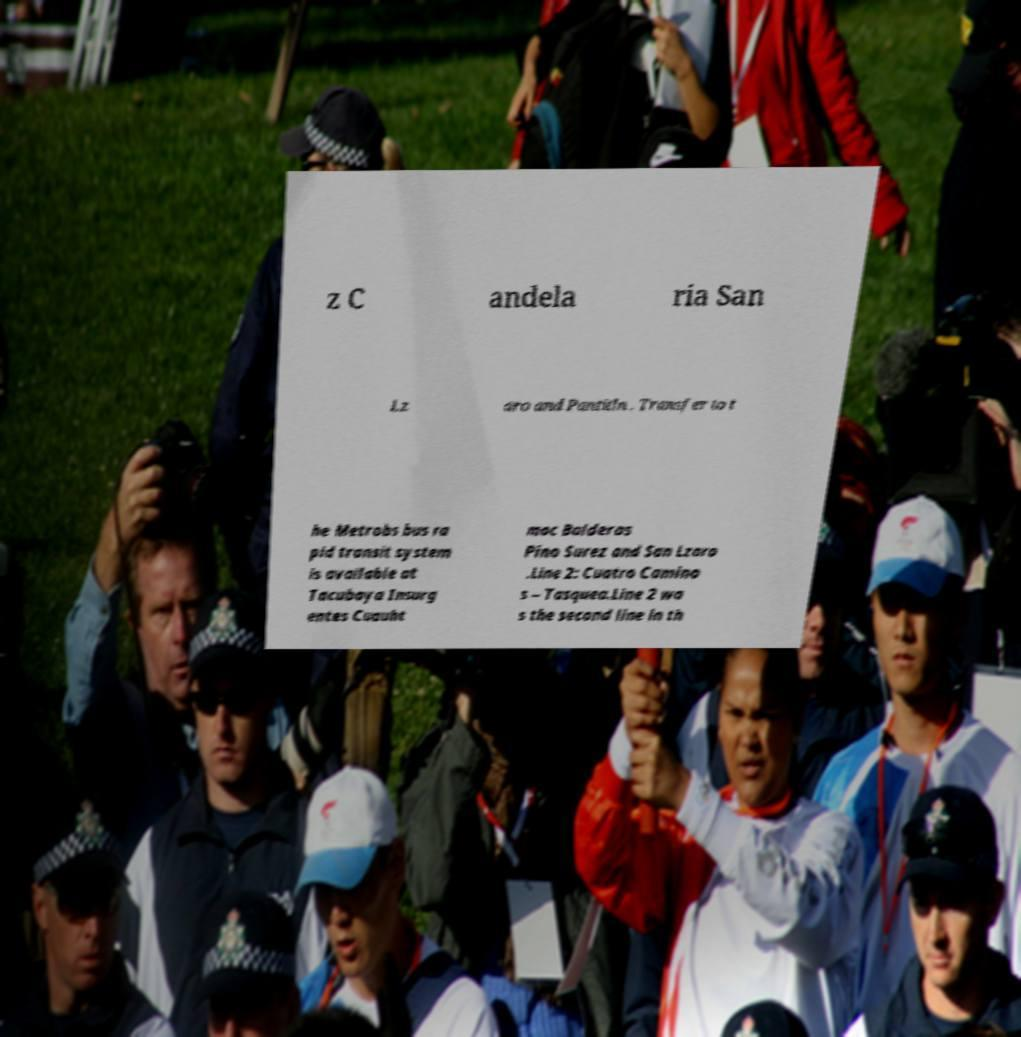What messages or text are displayed in this image? I need them in a readable, typed format. z C andela ria San Lz aro and Pantitln . Transfer to t he Metrobs bus ra pid transit system is available at Tacubaya Insurg entes Cuauht moc Balderas Pino Surez and San Lzaro .Line 2: Cuatro Camino s – Tasquea.Line 2 wa s the second line in th 